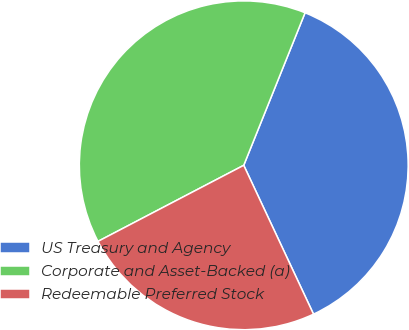Convert chart to OTSL. <chart><loc_0><loc_0><loc_500><loc_500><pie_chart><fcel>US Treasury and Agency<fcel>Corporate and Asset-Backed (a)<fcel>Redeemable Preferred Stock<nl><fcel>36.94%<fcel>38.74%<fcel>24.32%<nl></chart> 